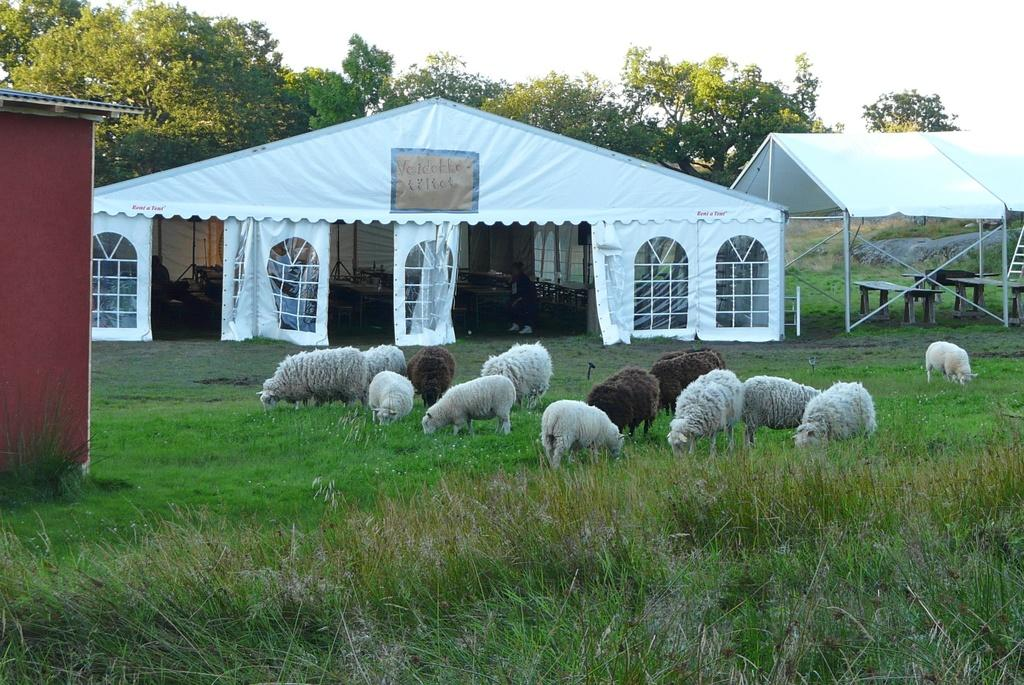What type of animals can be seen in the image? There are sheeps in the image. What type of vegetation is present in the image? There is grass in the image. What type of furniture is visible in the image? There are tables in the image. What type of temporary shelter is present in the image? There are tents in the image. What type of natural scenery can be seen in the image? There are trees in the image. What is visible in the background of the image? The sky is visible in the background of the image. What part of the sheep is being used for educational purposes in the image? There is no indication in the image that any part of the sheep is being used for educational purposes. Can you see a dock in the image? There is no dock present in the image. 